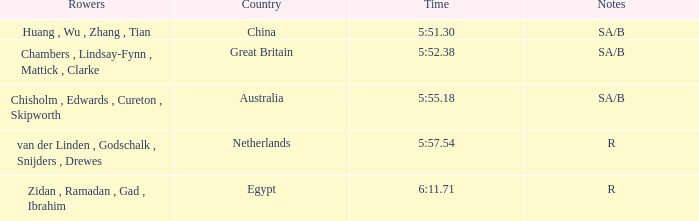What country has sa/b as the notes, and a time of 5:51.30? China. 